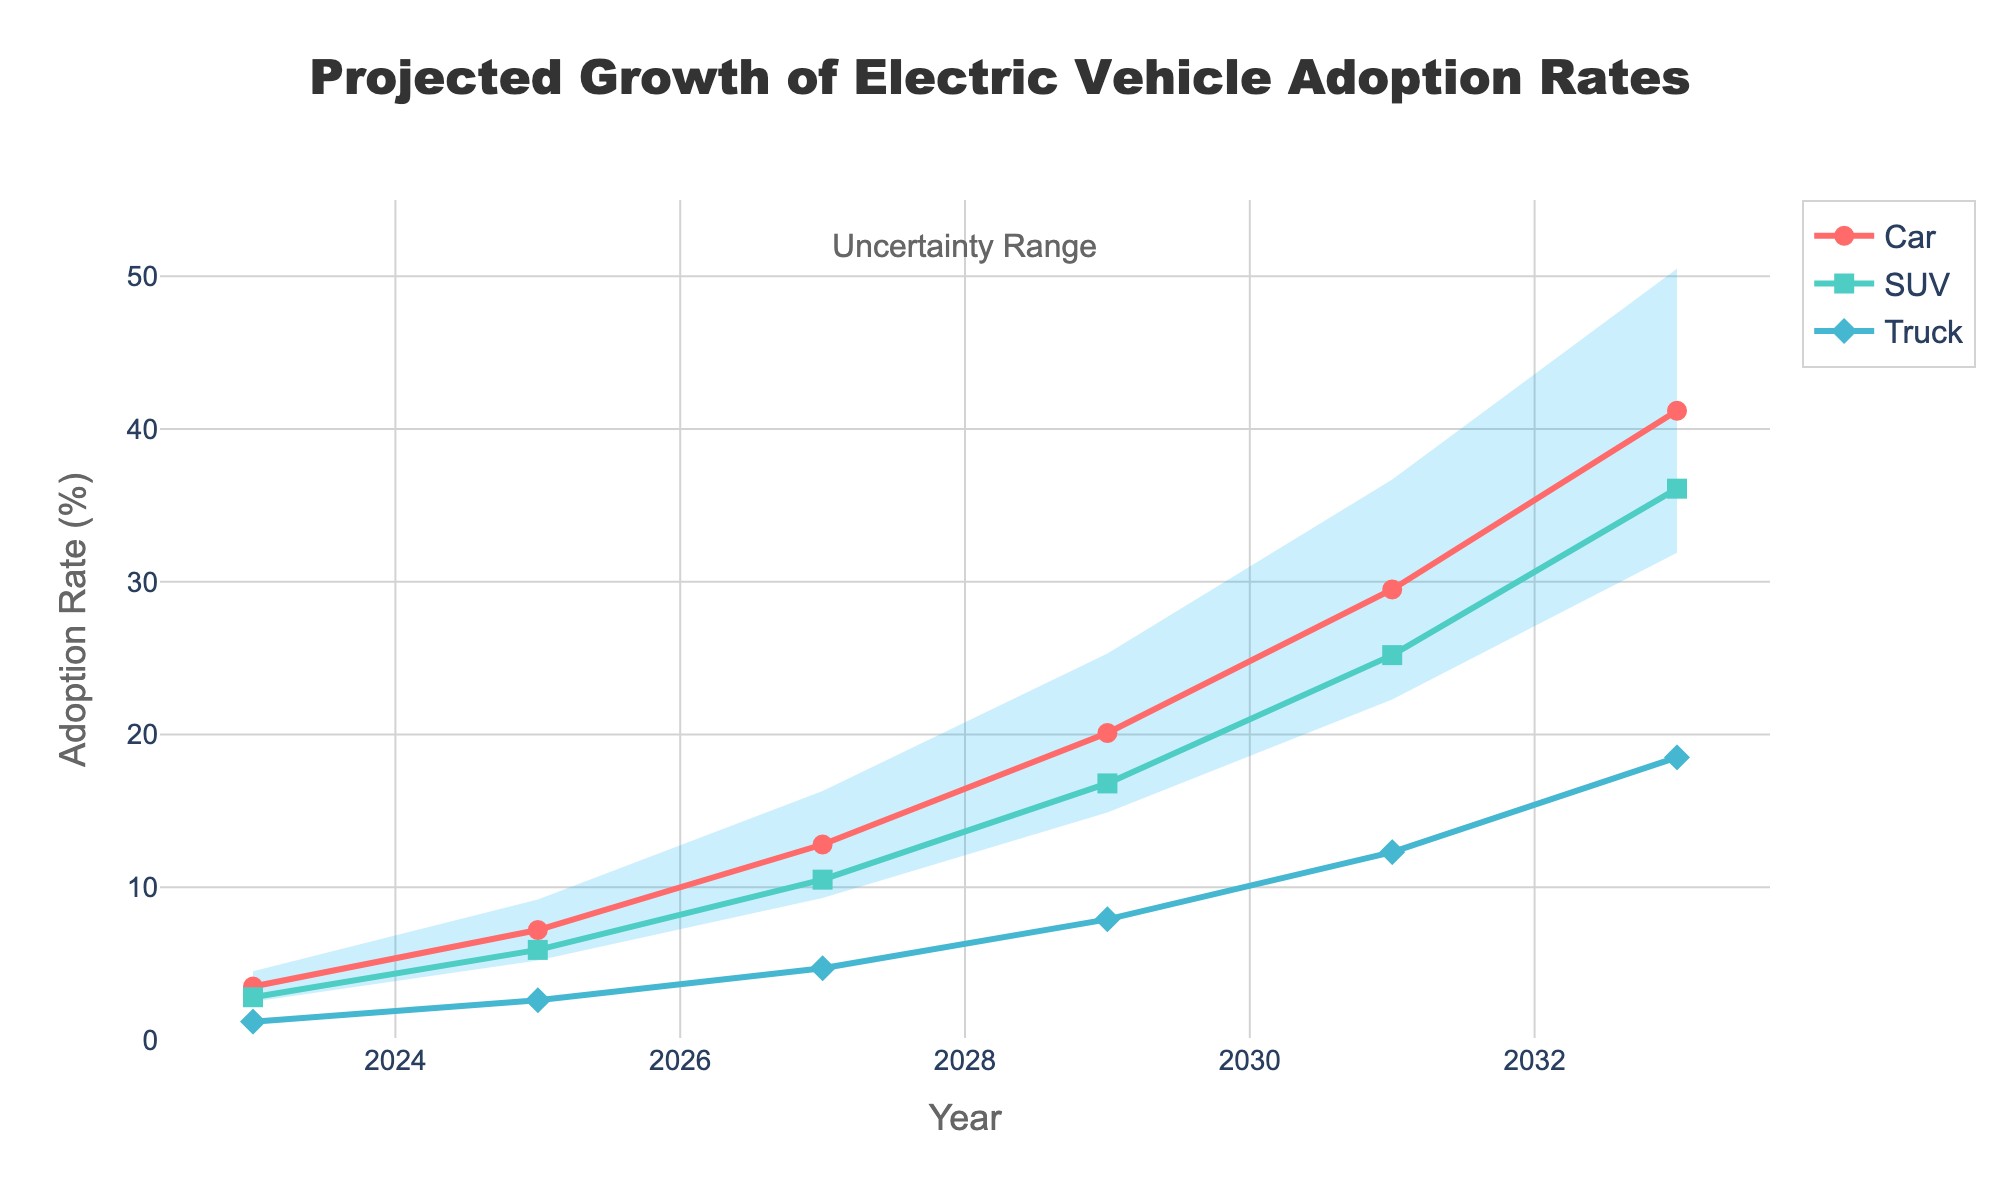what is the title of the figure? The title of the figure is located at the top and is clearly displayed.
Answer: Projected Growth of Electric Vehicle Adoption Rates How many vehicle types are represented in the figure? The legend lists all the vehicle types, and they are also shown with different colored lines and markers in the figure.
Answer: Three In which year does the adoption rate of cars exceed 20%? By observing the red line representing cars, you can see that it exceeds 20% in the year 2029.
Answer: 2029 What is the lowest adoption rate projected for trucks in the year 2025? Locate the data point for trucks in 2025, and note that the adoption rate is given as 2.6%.
Answer: 2.6% Between 2027 and 2029, which vehicle type shows the greatest increase in adoption rate? By looking at the slopes of the lines between 2027 and 2029, the car line shows the greatest increase from 12.8% to 20.1%.
Answer: Car What is the projected adoption rate range for the year 2031? The fan chart shaded area for 2031 gives the low and high estimates.
Answer: 22.3% - 36.7% How do the adoption rates for SUVs and Trucks in 2031 compare? For 2031, the SUV rate is 25.2% and the Truck rate is 12.3%. Comparing these values shows that SUV adoption is higher than Truck adoption in 2031.
Answer: SUV > Truck In which year do trucks show the least amount of growth in adoption rates? By assessing the slopes and data points for trucks over the years, the smallest increase is from 2023 to 2025 (1.2% to 2.6%).
Answer: 2023 - 2025 What is the average projected adoption rate for cars in 2027, 2029, and 2031? Sum the adoption rates for cars in 2027, 2029, and 2031 (12.8% + 20.1% + 29.5%) and divide by 3 to get the average.
Answer: 20.8% What does the shaded area in the figure represent? The shaded area between the low and high estimate lines indicates the range of uncertainty for the adoption rates.
Answer: Uncertainty Range 